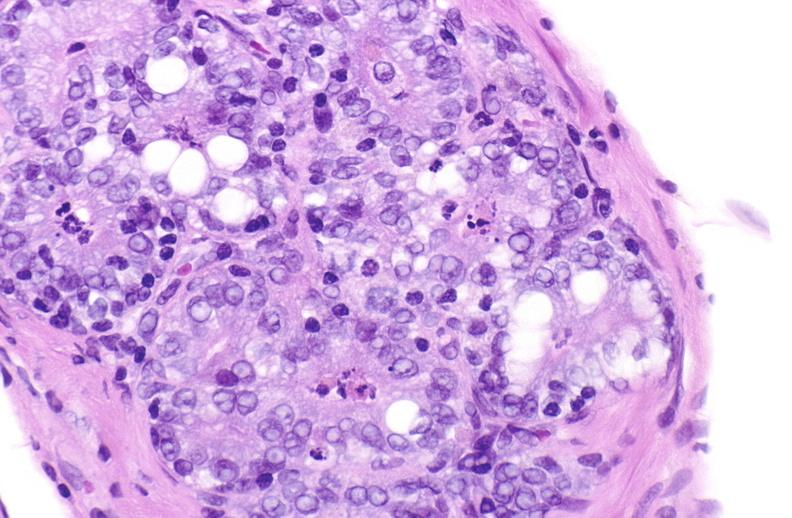what does this image show?
Answer the question using a single word or phrase. Apoptosis in prostate after orchiectomy 